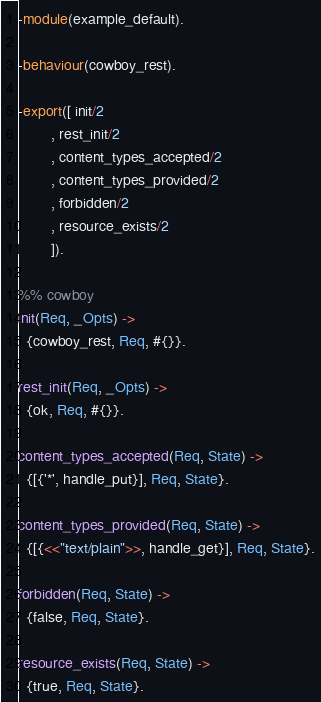<code> <loc_0><loc_0><loc_500><loc_500><_Erlang_>-module(example_default).

-behaviour(cowboy_rest).

-export([ init/2
        , rest_init/2
        , content_types_accepted/2
        , content_types_provided/2
        , forbidden/2
        , resource_exists/2
        ]).

%% cowboy
init(Req, _Opts) ->
  {cowboy_rest, Req, #{}}.

rest_init(Req, _Opts) ->
  {ok, Req, #{}}.

content_types_accepted(Req, State) ->
  {[{'*', handle_put}], Req, State}.

content_types_provided(Req, State) ->
  {[{<<"text/plain">>, handle_get}], Req, State}.

forbidden(Req, State) ->
  {false, Req, State}.

resource_exists(Req, State) ->
  {true, Req, State}.
</code> 